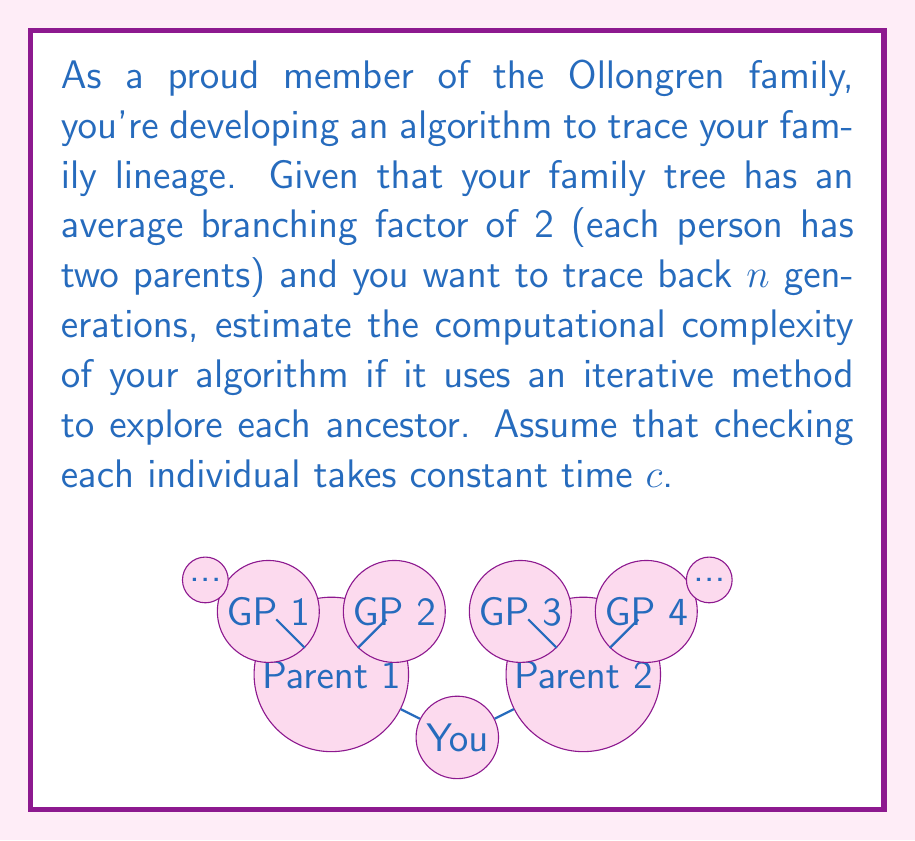What is the answer to this math problem? Let's approach this step-by-step:

1) In a binary tree-like structure (which a family tree approximates), the number of individuals at each generation doubles:
   - Generation 0 (you): $2^0 = 1$ person
   - Generation 1 (parents): $2^1 = 2$ people
   - Generation 2 (grandparents): $2^2 = 4$ people
   - ...
   - Generation $n$: $2^n$ people

2) The total number of individuals to check up to generation $n$ is the sum of this geometric series:

   $$S_n = 1 + 2 + 4 + ... + 2^n = \sum_{i=0}^n 2^i = 2^{n+1} - 1$$

3) If checking each individual takes constant time $c$, then the total time $T(n)$ is:

   $$T(n) = c(2^{n+1} - 1)$$

4) In Big O notation, we ignore constants and lower-order terms. Therefore:

   $$T(n) \in O(2^n)$$

5) This is an exponential time complexity, which is typical for exhaustive searches in tree-like structures.
Answer: $O(2^n)$ 